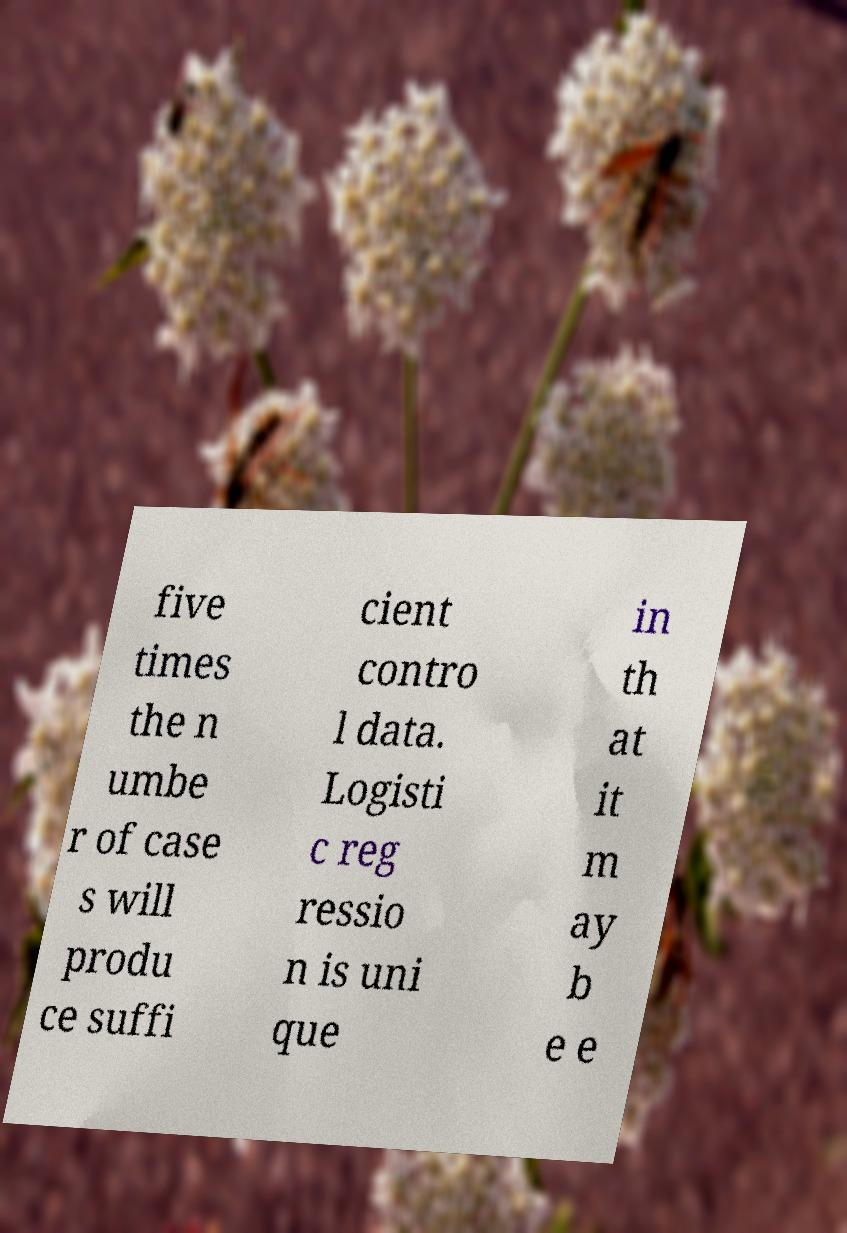What messages or text are displayed in this image? I need them in a readable, typed format. five times the n umbe r of case s will produ ce suffi cient contro l data. Logisti c reg ressio n is uni que in th at it m ay b e e 